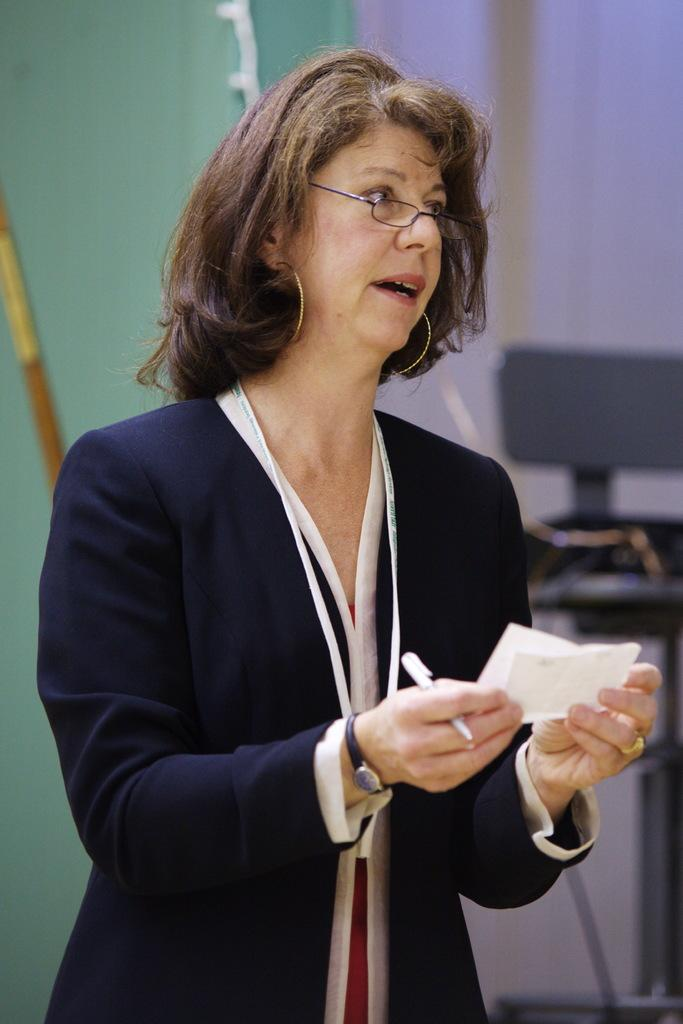Who is present in the image? There is a lady in the image. What is the lady holding in her hand? The lady is holding a pen and a paper. What can be seen in the background of the image? There is a curtain and a wall visible in the image. What type of bait is the lady using to catch fish in the image? There is no indication of fishing or bait in the image; the lady is holding a pen and a paper. What scientific experiment is the lady conducting in the image? There is no scientific experiment or indication of one in the image; the lady is simply holding a pen and a paper. 